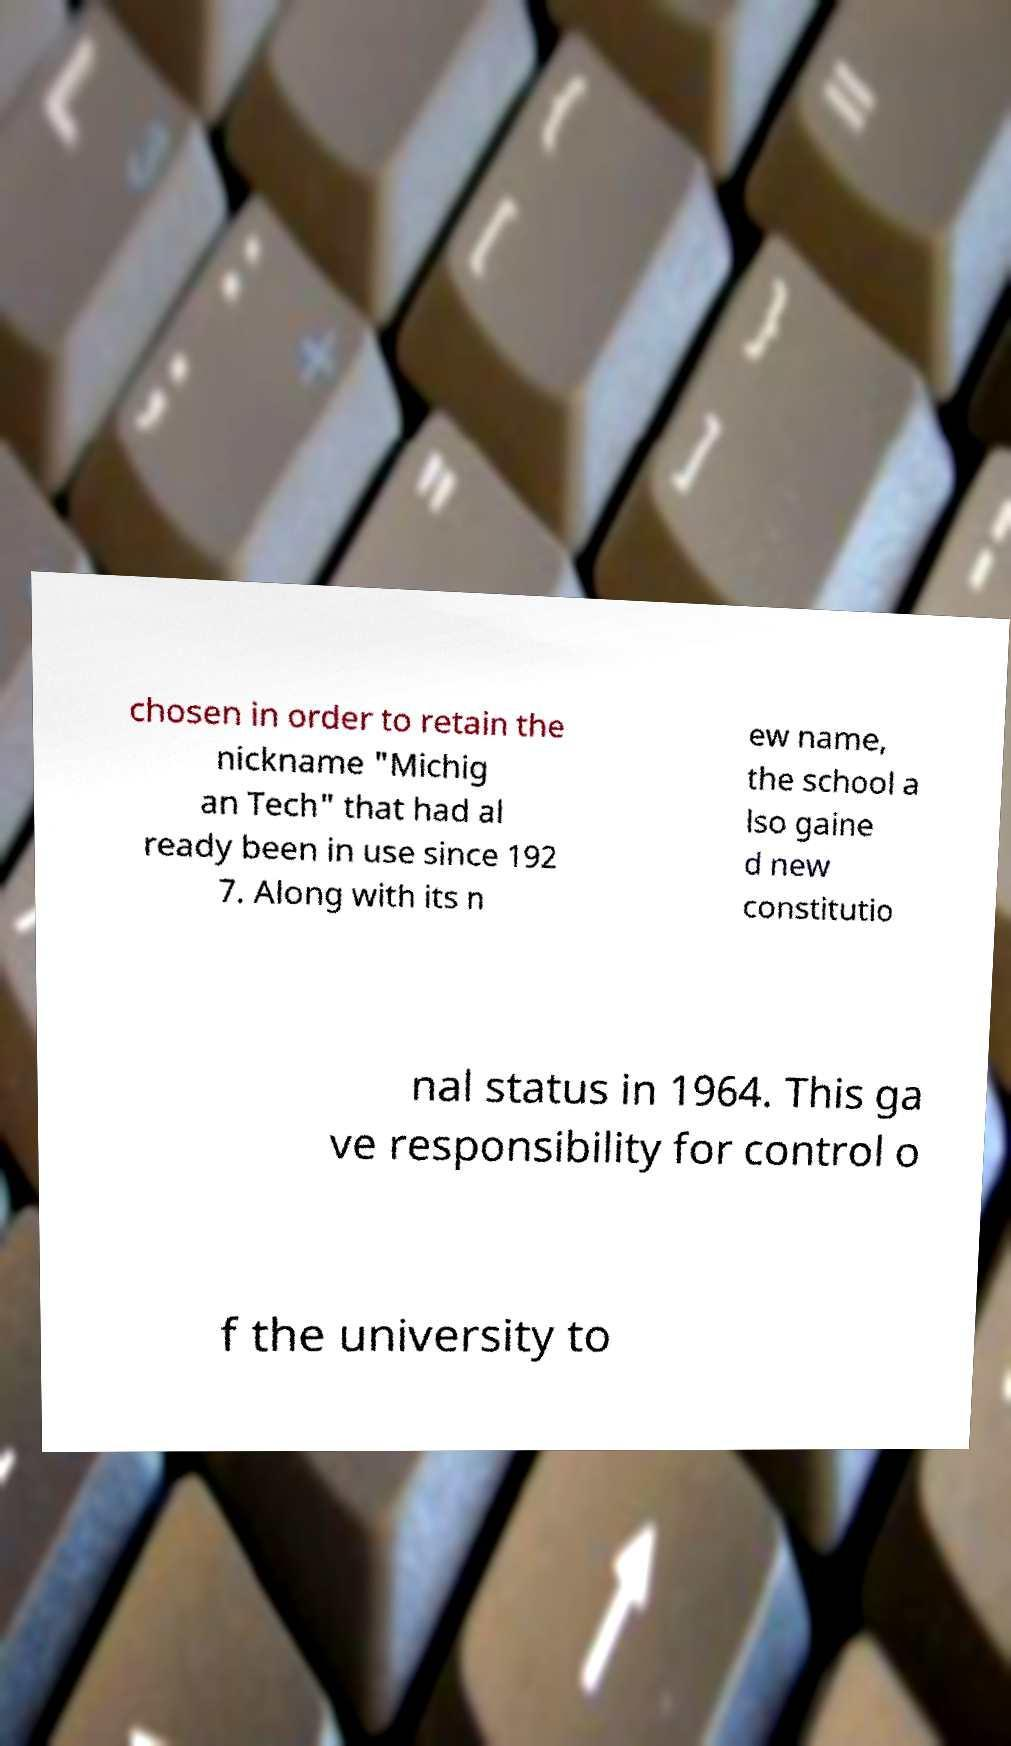I need the written content from this picture converted into text. Can you do that? chosen in order to retain the nickname "Michig an Tech" that had al ready been in use since 192 7. Along with its n ew name, the school a lso gaine d new constitutio nal status in 1964. This ga ve responsibility for control o f the university to 